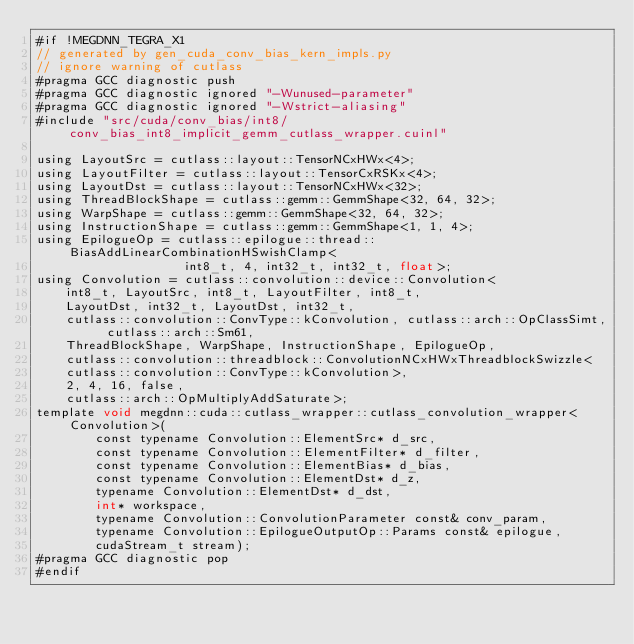<code> <loc_0><loc_0><loc_500><loc_500><_Cuda_>#if !MEGDNN_TEGRA_X1
// generated by gen_cuda_conv_bias_kern_impls.py
// ignore warning of cutlass
#pragma GCC diagnostic push
#pragma GCC diagnostic ignored "-Wunused-parameter"
#pragma GCC diagnostic ignored "-Wstrict-aliasing"
#include "src/cuda/conv_bias/int8/conv_bias_int8_implicit_gemm_cutlass_wrapper.cuinl"

using LayoutSrc = cutlass::layout::TensorNCxHWx<4>;
using LayoutFilter = cutlass::layout::TensorCxRSKx<4>;
using LayoutDst = cutlass::layout::TensorNCxHWx<32>;
using ThreadBlockShape = cutlass::gemm::GemmShape<32, 64, 32>;
using WarpShape = cutlass::gemm::GemmShape<32, 64, 32>;
using InstructionShape = cutlass::gemm::GemmShape<1, 1, 4>;
using EpilogueOp = cutlass::epilogue::thread::BiasAddLinearCombinationHSwishClamp<
                    int8_t, 4, int32_t, int32_t, float>;
using Convolution = cutlass::convolution::device::Convolution<
    int8_t, LayoutSrc, int8_t, LayoutFilter, int8_t, 
    LayoutDst, int32_t, LayoutDst, int32_t, 
    cutlass::convolution::ConvType::kConvolution, cutlass::arch::OpClassSimt, cutlass::arch::Sm61, 
    ThreadBlockShape, WarpShape, InstructionShape, EpilogueOp, 
    cutlass::convolution::threadblock::ConvolutionNCxHWxThreadblockSwizzle<
    cutlass::convolution::ConvType::kConvolution>, 
    2, 4, 16, false, 
    cutlass::arch::OpMultiplyAddSaturate>;
template void megdnn::cuda::cutlass_wrapper::cutlass_convolution_wrapper<Convolution>(
        const typename Convolution::ElementSrc* d_src, 
        const typename Convolution::ElementFilter* d_filter, 
        const typename Convolution::ElementBias* d_bias, 
        const typename Convolution::ElementDst* d_z, 
        typename Convolution::ElementDst* d_dst, 
        int* workspace, 
        typename Convolution::ConvolutionParameter const& conv_param, 
        typename Convolution::EpilogueOutputOp::Params const& epilogue, 
        cudaStream_t stream);
#pragma GCC diagnostic pop
#endif
</code> 